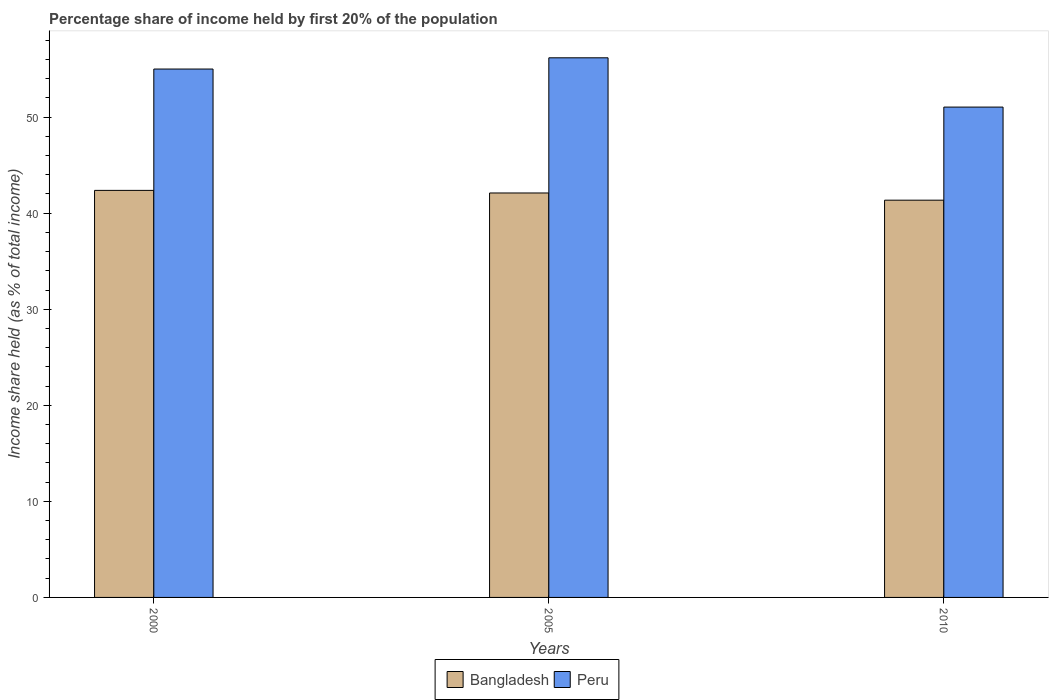How many groups of bars are there?
Give a very brief answer. 3. Are the number of bars on each tick of the X-axis equal?
Your answer should be very brief. Yes. How many bars are there on the 2nd tick from the left?
Offer a very short reply. 2. What is the label of the 1st group of bars from the left?
Offer a very short reply. 2000. In how many cases, is the number of bars for a given year not equal to the number of legend labels?
Provide a succinct answer. 0. Across all years, what is the maximum share of income held by first 20% of the population in Bangladesh?
Your answer should be very brief. 42.37. Across all years, what is the minimum share of income held by first 20% of the population in Peru?
Give a very brief answer. 51.04. What is the total share of income held by first 20% of the population in Bangladesh in the graph?
Offer a terse response. 125.82. What is the difference between the share of income held by first 20% of the population in Bangladesh in 2000 and that in 2005?
Make the answer very short. 0.27. What is the difference between the share of income held by first 20% of the population in Peru in 2000 and the share of income held by first 20% of the population in Bangladesh in 2010?
Your answer should be compact. 13.65. What is the average share of income held by first 20% of the population in Peru per year?
Provide a succinct answer. 54.07. In the year 2005, what is the difference between the share of income held by first 20% of the population in Bangladesh and share of income held by first 20% of the population in Peru?
Make the answer very short. -14.07. What is the ratio of the share of income held by first 20% of the population in Peru in 2005 to that in 2010?
Ensure brevity in your answer.  1.1. Is the share of income held by first 20% of the population in Bangladesh in 2005 less than that in 2010?
Your answer should be compact. No. What is the difference between the highest and the second highest share of income held by first 20% of the population in Bangladesh?
Your answer should be very brief. 0.27. What is the difference between the highest and the lowest share of income held by first 20% of the population in Peru?
Offer a terse response. 5.13. Is the sum of the share of income held by first 20% of the population in Bangladesh in 2000 and 2010 greater than the maximum share of income held by first 20% of the population in Peru across all years?
Your response must be concise. Yes. What does the 2nd bar from the right in 2010 represents?
Ensure brevity in your answer.  Bangladesh. How many years are there in the graph?
Your answer should be compact. 3. Are the values on the major ticks of Y-axis written in scientific E-notation?
Your response must be concise. No. Does the graph contain grids?
Your answer should be very brief. No. How many legend labels are there?
Ensure brevity in your answer.  2. What is the title of the graph?
Offer a very short reply. Percentage share of income held by first 20% of the population. Does "Mongolia" appear as one of the legend labels in the graph?
Offer a terse response. No. What is the label or title of the X-axis?
Give a very brief answer. Years. What is the label or title of the Y-axis?
Provide a succinct answer. Income share held (as % of total income). What is the Income share held (as % of total income) of Bangladesh in 2000?
Provide a short and direct response. 42.37. What is the Income share held (as % of total income) of Peru in 2000?
Ensure brevity in your answer.  55. What is the Income share held (as % of total income) in Bangladesh in 2005?
Your answer should be compact. 42.1. What is the Income share held (as % of total income) in Peru in 2005?
Keep it short and to the point. 56.17. What is the Income share held (as % of total income) of Bangladesh in 2010?
Ensure brevity in your answer.  41.35. What is the Income share held (as % of total income) of Peru in 2010?
Keep it short and to the point. 51.04. Across all years, what is the maximum Income share held (as % of total income) of Bangladesh?
Make the answer very short. 42.37. Across all years, what is the maximum Income share held (as % of total income) in Peru?
Provide a short and direct response. 56.17. Across all years, what is the minimum Income share held (as % of total income) in Bangladesh?
Provide a succinct answer. 41.35. Across all years, what is the minimum Income share held (as % of total income) in Peru?
Your answer should be very brief. 51.04. What is the total Income share held (as % of total income) in Bangladesh in the graph?
Provide a succinct answer. 125.82. What is the total Income share held (as % of total income) of Peru in the graph?
Your response must be concise. 162.21. What is the difference between the Income share held (as % of total income) of Bangladesh in 2000 and that in 2005?
Make the answer very short. 0.27. What is the difference between the Income share held (as % of total income) in Peru in 2000 and that in 2005?
Your response must be concise. -1.17. What is the difference between the Income share held (as % of total income) of Peru in 2000 and that in 2010?
Keep it short and to the point. 3.96. What is the difference between the Income share held (as % of total income) of Peru in 2005 and that in 2010?
Make the answer very short. 5.13. What is the difference between the Income share held (as % of total income) in Bangladesh in 2000 and the Income share held (as % of total income) in Peru in 2010?
Give a very brief answer. -8.67. What is the difference between the Income share held (as % of total income) in Bangladesh in 2005 and the Income share held (as % of total income) in Peru in 2010?
Your answer should be very brief. -8.94. What is the average Income share held (as % of total income) of Bangladesh per year?
Give a very brief answer. 41.94. What is the average Income share held (as % of total income) of Peru per year?
Provide a succinct answer. 54.07. In the year 2000, what is the difference between the Income share held (as % of total income) of Bangladesh and Income share held (as % of total income) of Peru?
Your response must be concise. -12.63. In the year 2005, what is the difference between the Income share held (as % of total income) of Bangladesh and Income share held (as % of total income) of Peru?
Offer a terse response. -14.07. In the year 2010, what is the difference between the Income share held (as % of total income) of Bangladesh and Income share held (as % of total income) of Peru?
Give a very brief answer. -9.69. What is the ratio of the Income share held (as % of total income) of Bangladesh in 2000 to that in 2005?
Keep it short and to the point. 1.01. What is the ratio of the Income share held (as % of total income) in Peru in 2000 to that in 2005?
Give a very brief answer. 0.98. What is the ratio of the Income share held (as % of total income) of Bangladesh in 2000 to that in 2010?
Offer a very short reply. 1.02. What is the ratio of the Income share held (as % of total income) of Peru in 2000 to that in 2010?
Your answer should be compact. 1.08. What is the ratio of the Income share held (as % of total income) of Bangladesh in 2005 to that in 2010?
Ensure brevity in your answer.  1.02. What is the ratio of the Income share held (as % of total income) in Peru in 2005 to that in 2010?
Offer a very short reply. 1.1. What is the difference between the highest and the second highest Income share held (as % of total income) in Bangladesh?
Your response must be concise. 0.27. What is the difference between the highest and the second highest Income share held (as % of total income) of Peru?
Provide a succinct answer. 1.17. What is the difference between the highest and the lowest Income share held (as % of total income) in Peru?
Offer a terse response. 5.13. 